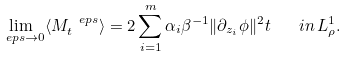<formula> <loc_0><loc_0><loc_500><loc_500>\lim _ { \ e p s \rightarrow 0 } \langle M ^ { \ e p s } _ { t } \rangle = 2 \sum _ { i = 1 } ^ { m } \alpha _ { i } \beta ^ { - 1 } \| \partial _ { z _ { i } } \phi \| ^ { 2 } t \quad i n \, L ^ { 1 } _ { \rho } .</formula> 